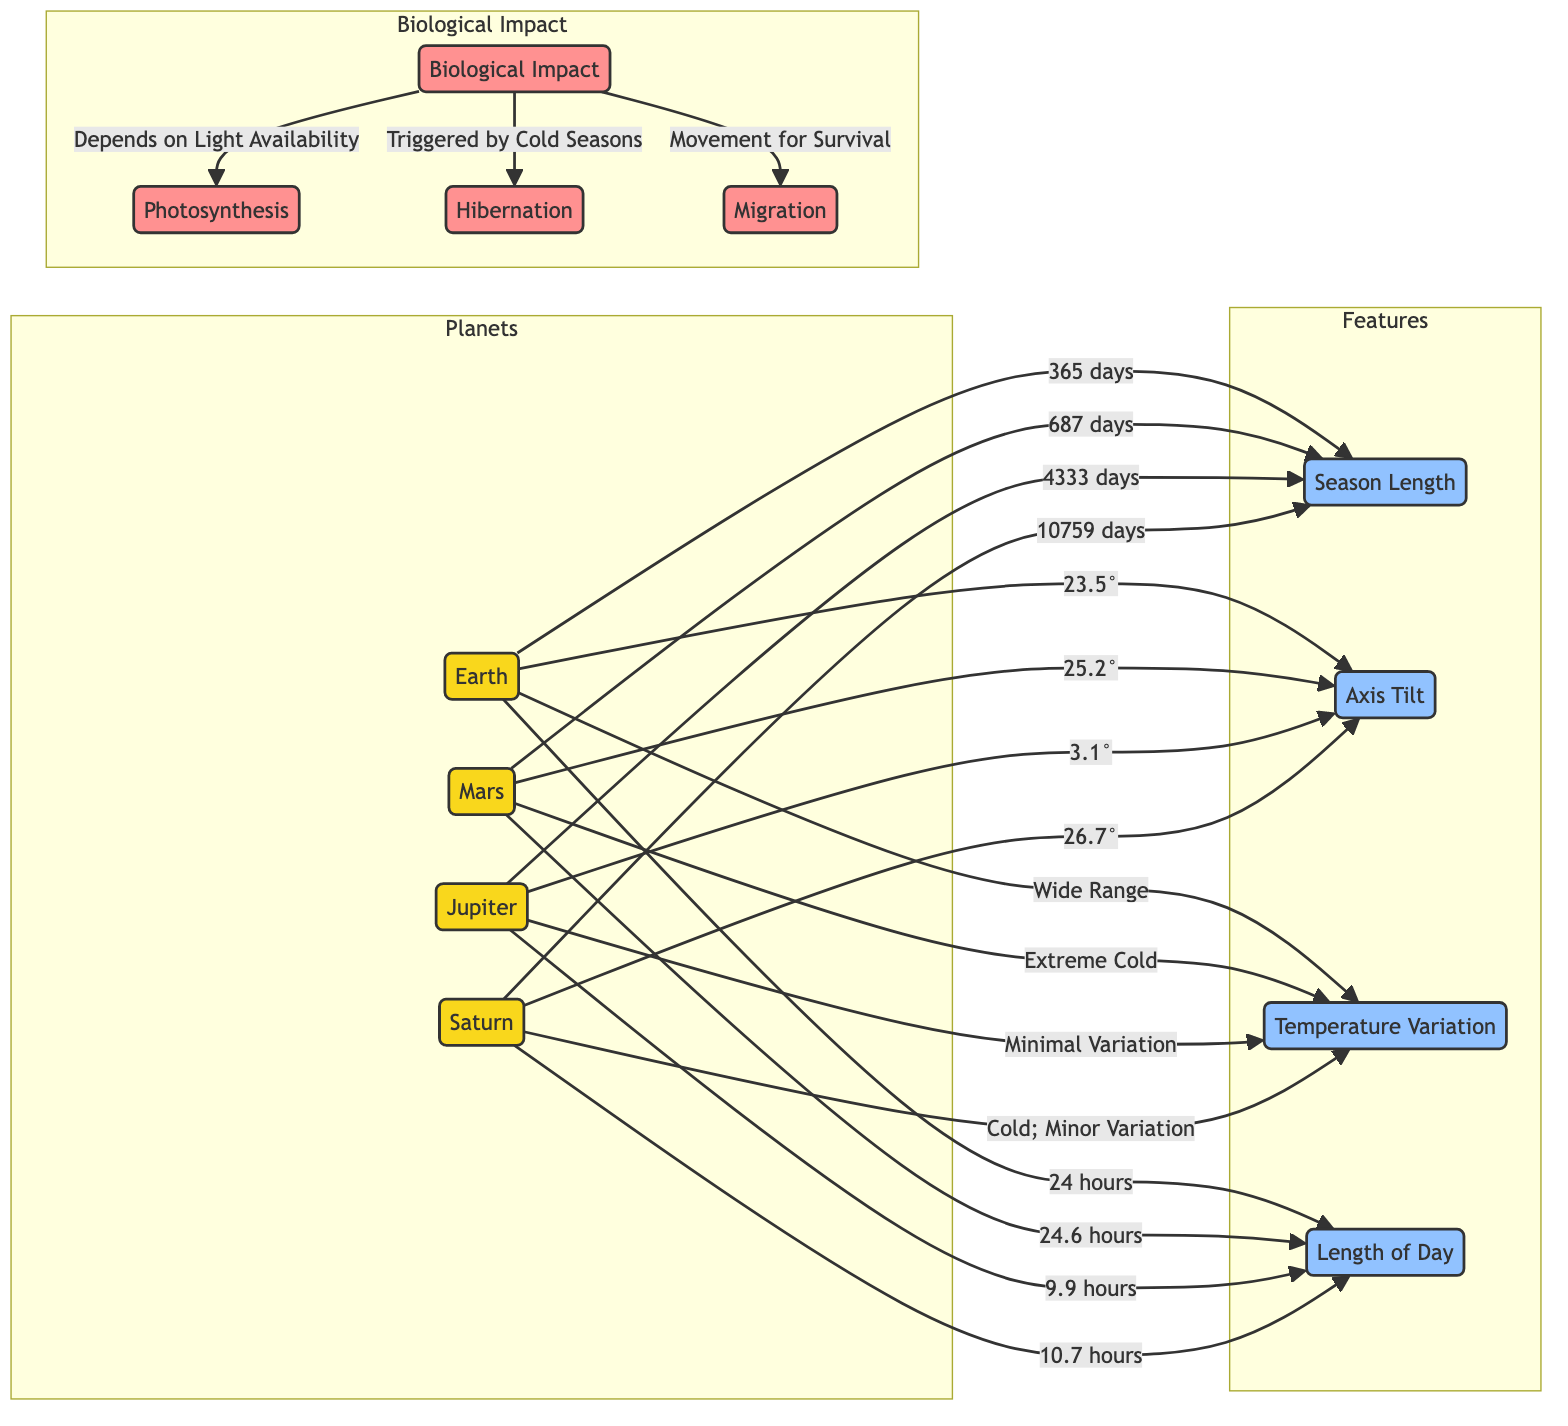What is the length of a Martian year? The diagram indicates that Mars has a seasonal length of 687 days. Thus, the length of a Martian year is equal to 687 days.
Answer: 687 days What is the axis tilt of Earth? The diagram shows that Earth has an axis tilt of 23.5 degrees. Hence, the axis tilt is 23.5 degrees.
Answer: 23.5 degrees Which planet has the minimal temperature variation? According to the diagram, Jupiter is described as having minimal temperature variation among the listed planets. Therefore, the answer is Jupiter.
Answer: Jupiter How long is a day on Saturn? The diagram specifies that Saturn has a day length of 10.7 hours. Therefore, the length of a day on Saturn is 10.7 hours.
Answer: 10.7 hours What biological impact is triggered by cold seasons? The diagram states that hibernation is triggered by cold seasons, indicating that this biological impact is related to seasonal temperature changes.
Answer: Hibernation Which planet has the widest temperature variation? The diagram shows that Earth features a wide range of temperature variation, making it the planet with the widest temperature variation in the diagram.
Answer: Earth How long is the year on Jupiter? The seasonal length for Jupiter is given as 4333 days, which means that the length of a year on Jupiter is 4333 days.
Answer: 4333 days What factors contribute to biological impacts on Earth? Based on the diagram, biological impacts on Earth depend on light availability, are triggered by cold seasons, and involve movement for survival, indicating that these three factors contribute to the impacts.
Answer: Light availability, cold seasons, movement for survival Which planet has the longest season length? The diagram indicates that Saturn has a season length of 10759 days, which is the longest among the listed planets. Thus, Saturn has the longest season length.
Answer: Saturn 